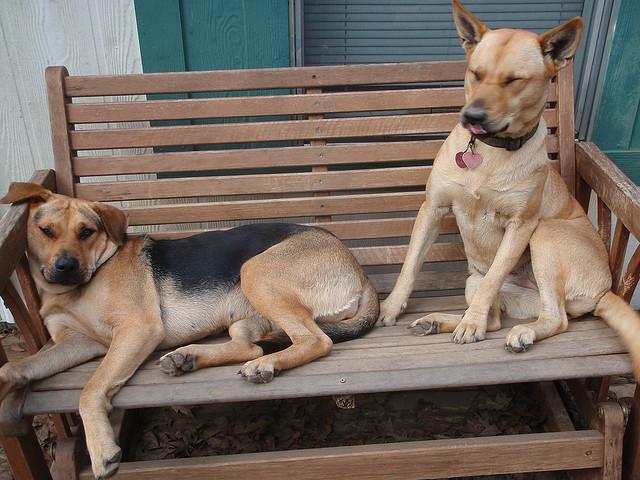Which dog's tongue is sticking out?
Concise answer only. Right. What is the bench made of?
Short answer required. Wood. Is the dog sticking his tongue out?
Give a very brief answer. Yes. 